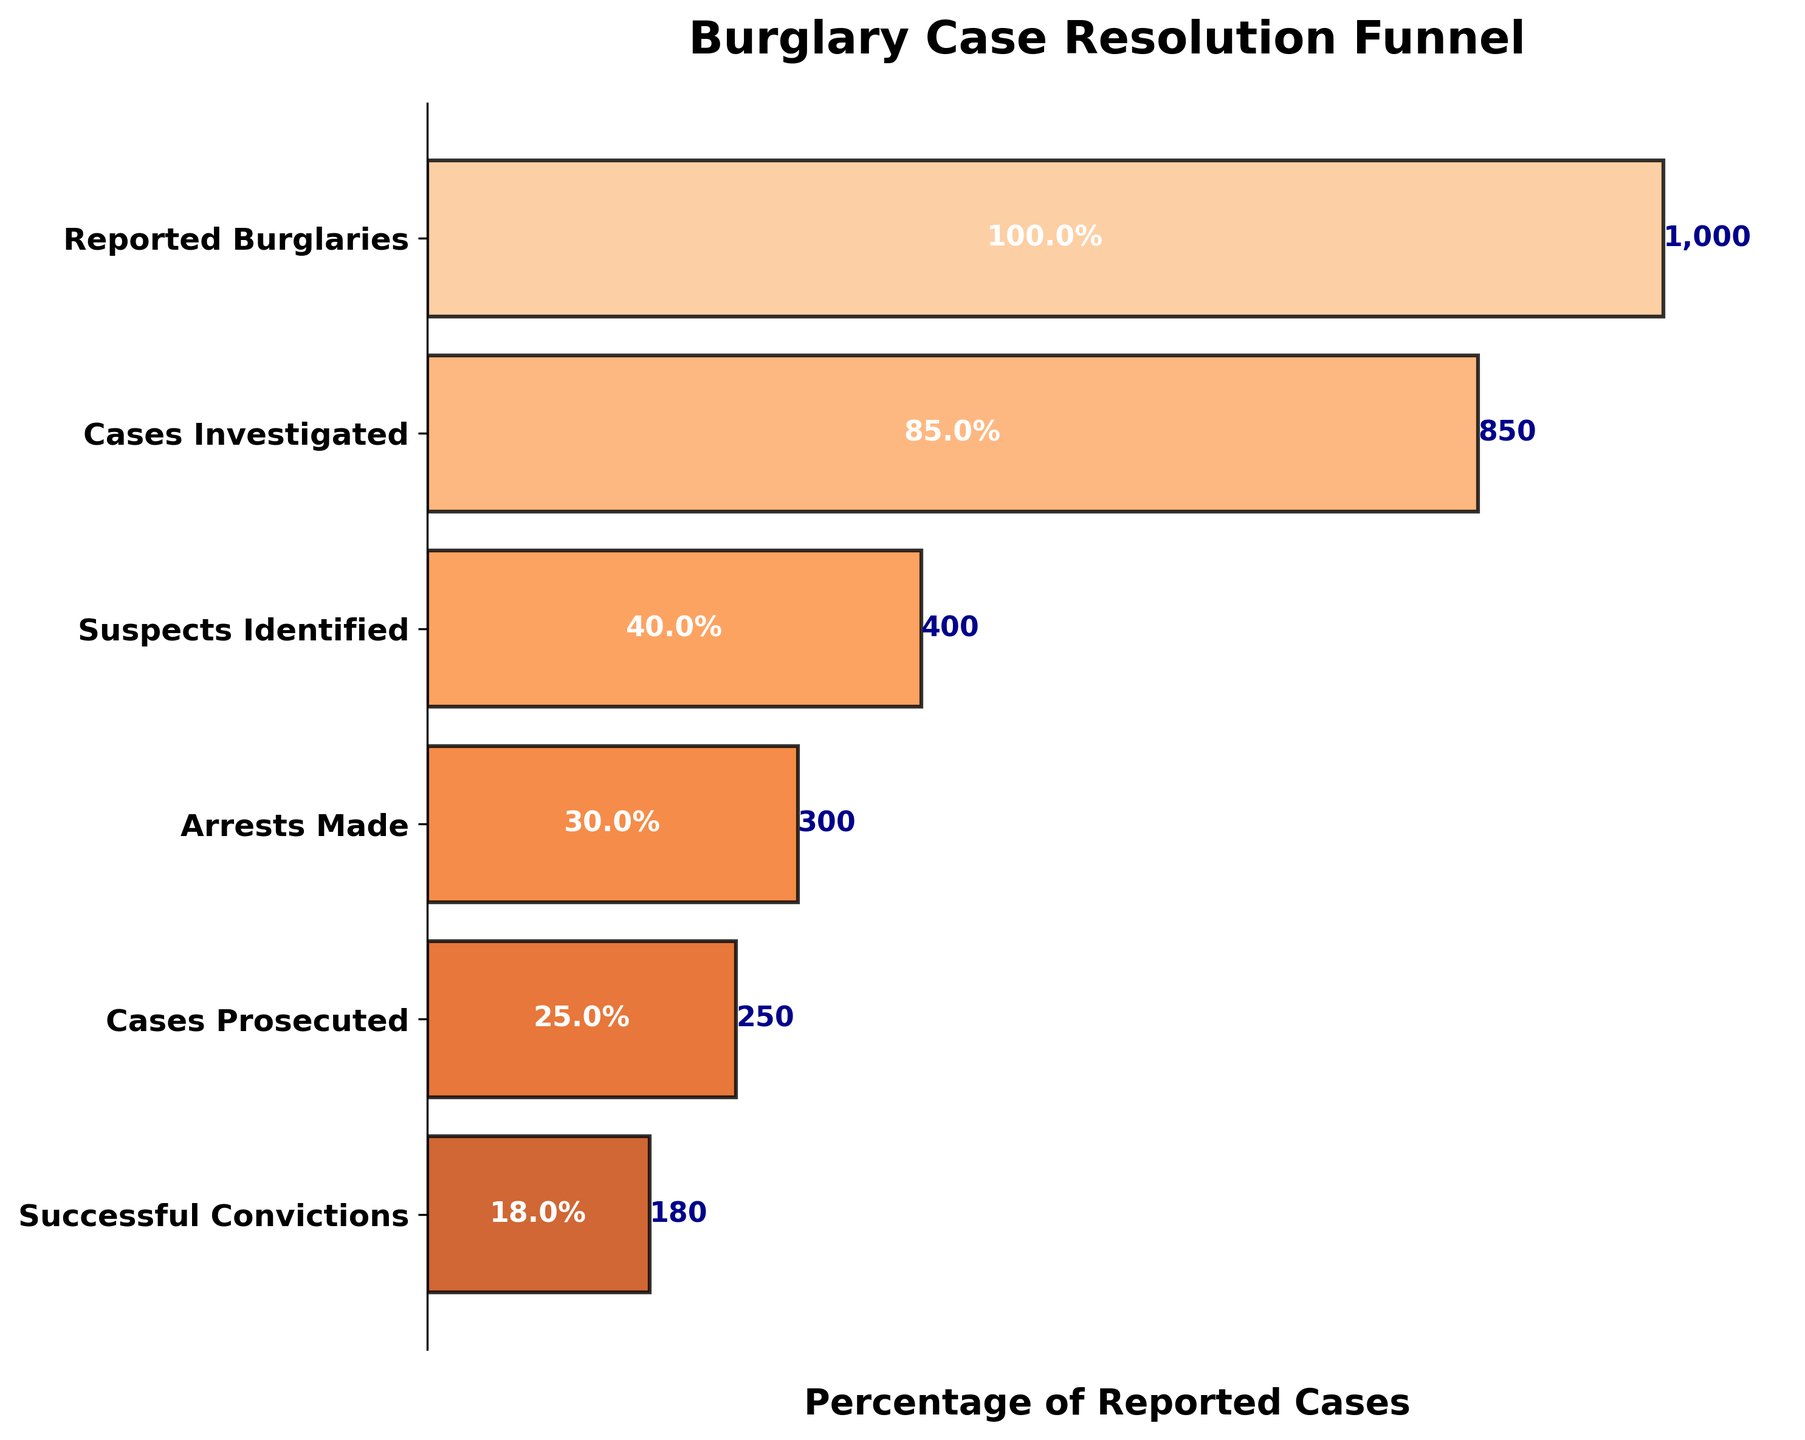What's the title of the figure? The title is located at the top of the plot, providing an overarching description of the visual information.
Answer: Burglary Case Resolution Funnel How many stages are presented in the funnel chart? By counting the number of horizontal bars or labels along the y-axis, you can determine the number of stages.
Answer: 6 Which stage has the greatest drop in case numbers compared to the previous stage? By observing the lengths of the horizontal bars, you can notice the difference between consecutive stages. The largest drop is detected by comparing each bar's length with the previous one.
Answer: Suspects Identified to Arrests Made What is the percentage of cases that resulted in successful convictions relative to reported burglaries? To find the percentage, divide the number of successful convictions (180) by the number of reported burglaries (1000) and multiply by 100.
Answer: 18% How many cases are prosecuted after arrests are made? Locate the 'Cases Prosecuted' and 'Arrests Made' stages on the chart, then read the numbers for each. The actual cases prosecuted are given directly in the 'Cases Prosecuted' stage.
Answer: 250 What percentage of cases investigated result in arrests? Calculate this by dividing the number of arrests made (300) by the number of cases investigated (850) and multiply by 100.
Answer: 35.3% Are there more cases investigated or suspects identified? Look at the lengths of the bars and the corresponding case numbers for 'Cases Investigated' and 'Suspects Identified'.
Answer: More cases investigated Which stage has the lowest number of cases? Identify the shortest bar in the funnel chart and its corresponding stage label.
Answer: Successful Convictions What is the difference in the number of cases between suspects identified and cases prosecuted? Subtract the number of cases prosecuted (250) from the number of suspects identified (400).
Answer: 150 Between which two consecutive stages is the highest percentage drop observed? Calculate the percentage drop for each pair of consecutive stages by using the formula: ((Number at Previous Stage - Number at Current Stage) / Number at Previous Stage) * 100. The highest value indicates the steepest drop.
Answer: Suspects Identified to Arrests Made 